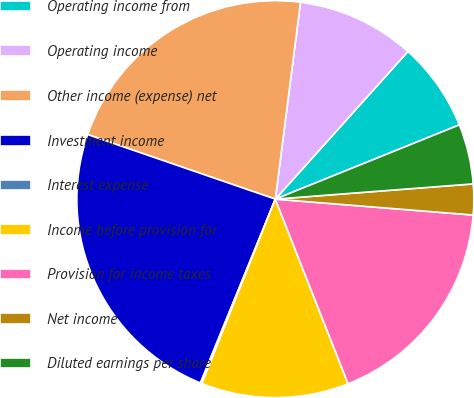Convert chart to OTSL. <chart><loc_0><loc_0><loc_500><loc_500><pie_chart><fcel>Operating income from<fcel>Operating income<fcel>Other income (expense) net<fcel>Investment income<fcel>Interest expense<fcel>Income before provision for<fcel>Provision for income taxes<fcel>Net income<fcel>Diluted earnings per share<nl><fcel>7.25%<fcel>9.62%<fcel>21.75%<fcel>24.12%<fcel>0.13%<fcel>12.0%<fcel>17.75%<fcel>2.5%<fcel>4.88%<nl></chart> 